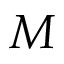Convert formula to latex. <formula><loc_0><loc_0><loc_500><loc_500>M</formula> 